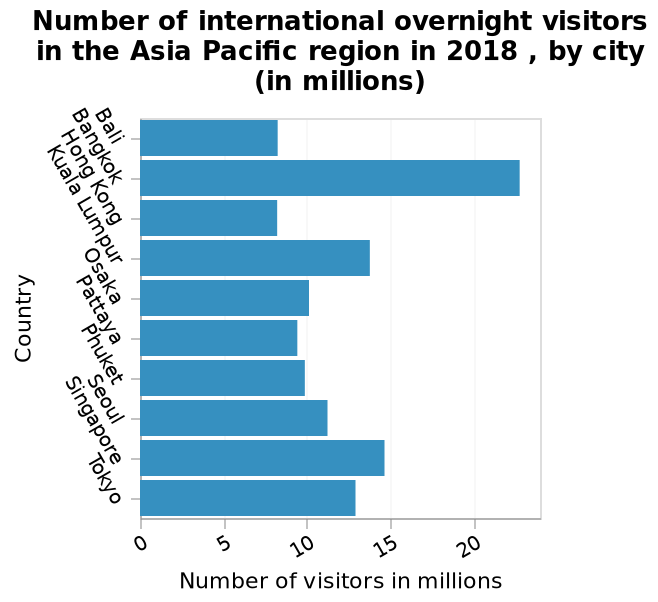<image>
How many international visitors does Bali have? Bali also has roughly 8 million international visitors. Which cities have the least number of international visitors?  Hong Kong and Bali have the least number of international visitors, with a number of roughly 8 million people. Offer a thorough analysis of the image. Bangkok has the most international visitors with over 20 million people visiting the city. Hong Kong and Bali have the least number of visitors with a number of roughly 8 million people. Kuala Lampur is the second most visited after Bangkok. 